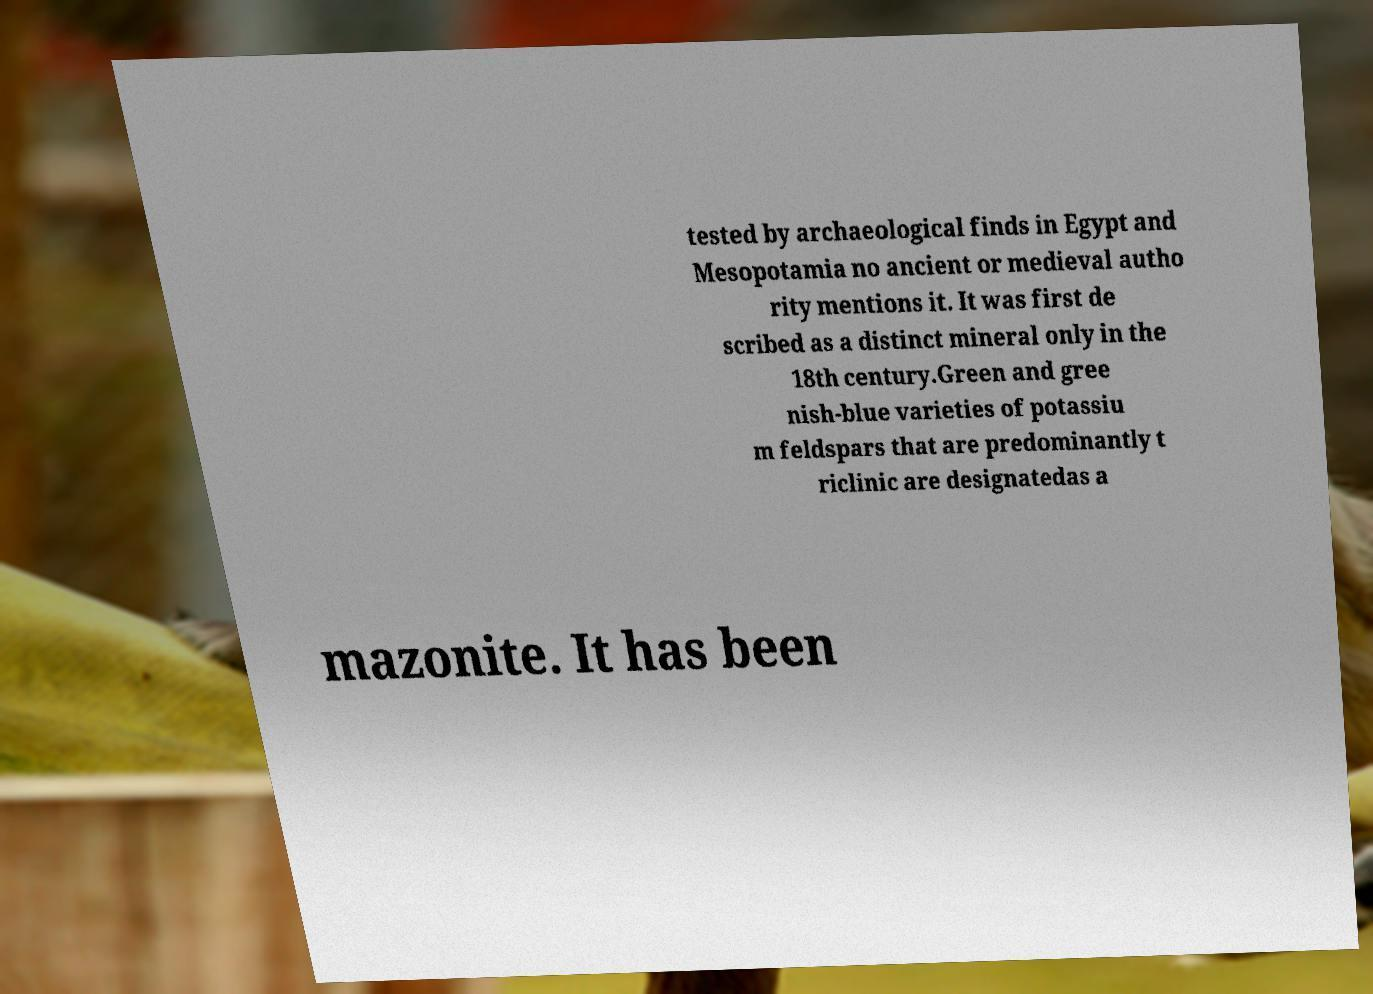Can you read and provide the text displayed in the image?This photo seems to have some interesting text. Can you extract and type it out for me? tested by archaeological finds in Egypt and Mesopotamia no ancient or medieval autho rity mentions it. It was first de scribed as a distinct mineral only in the 18th century.Green and gree nish-blue varieties of potassiu m feldspars that are predominantly t riclinic are designatedas a mazonite. It has been 